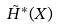<formula> <loc_0><loc_0><loc_500><loc_500>\tilde { H } ^ { * } ( X )</formula> 